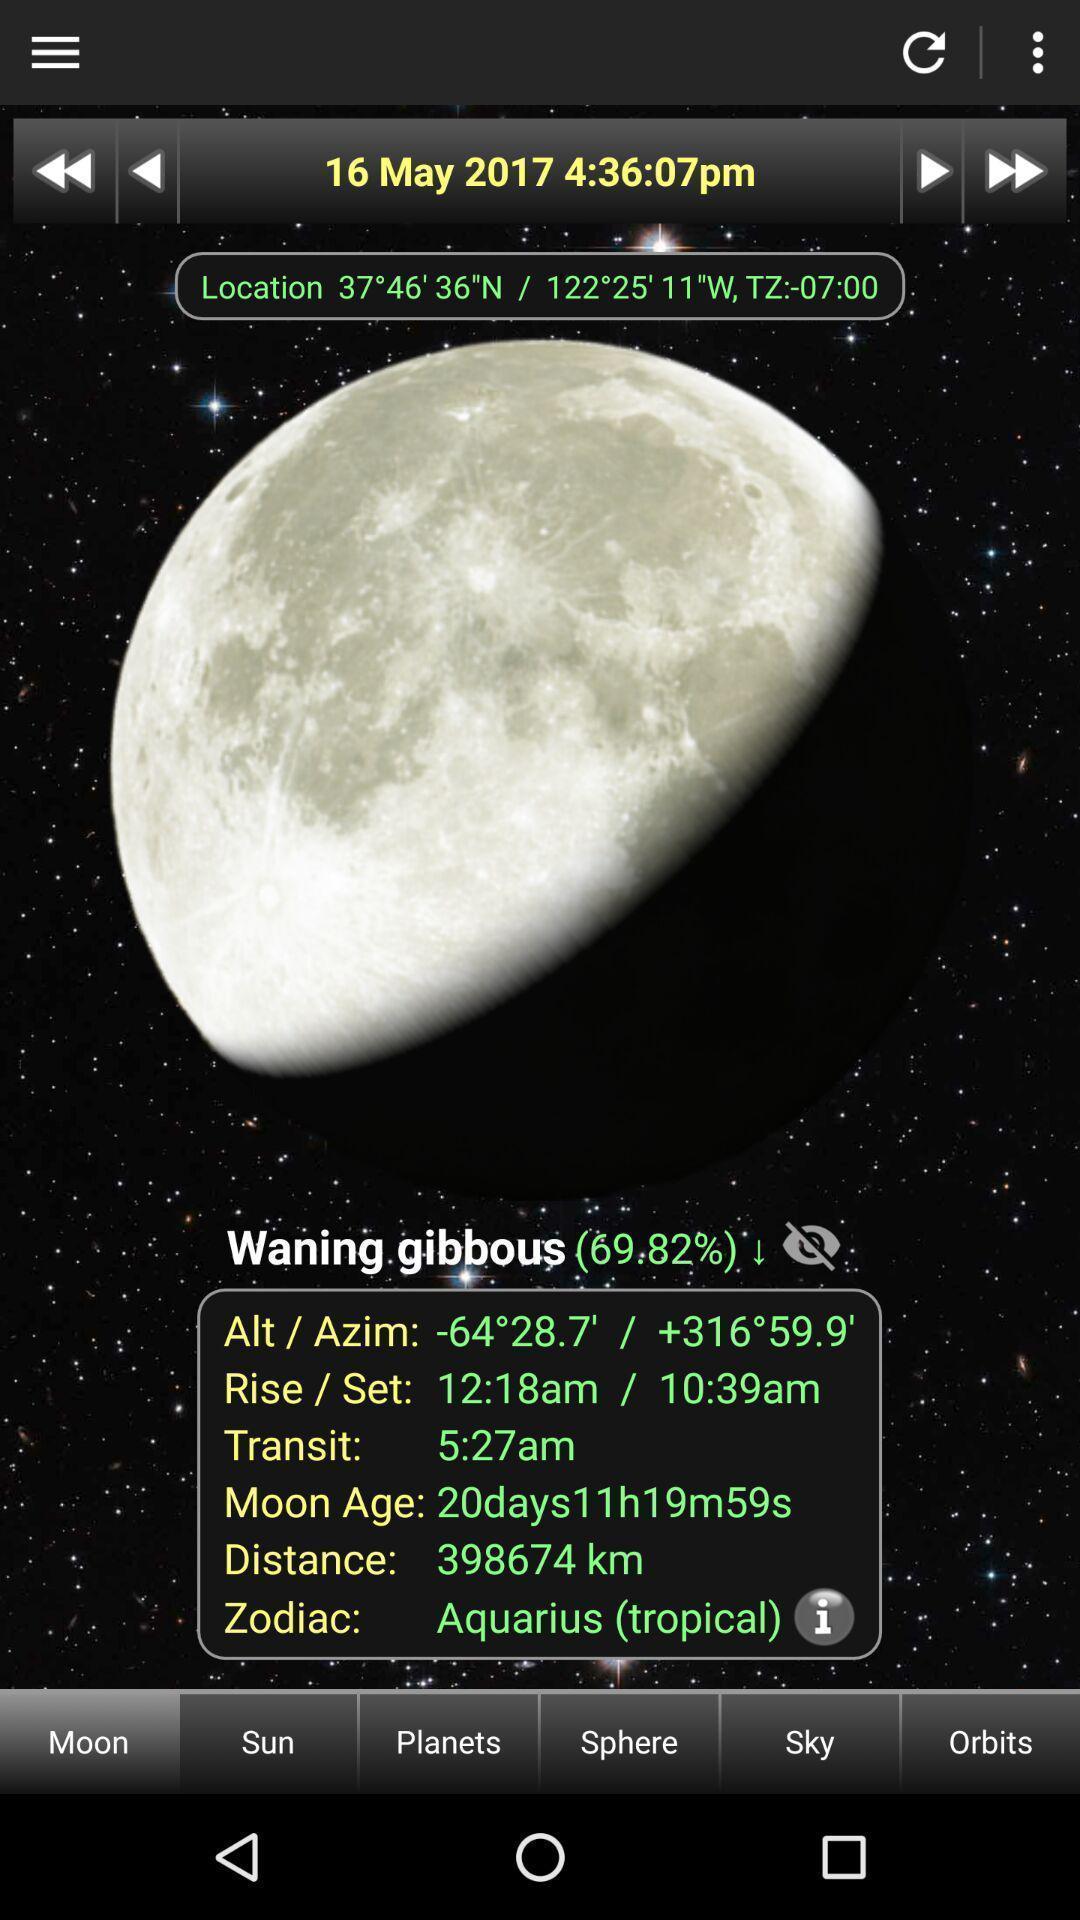Explain what's happening in this screen capture. Screen showing moon. 